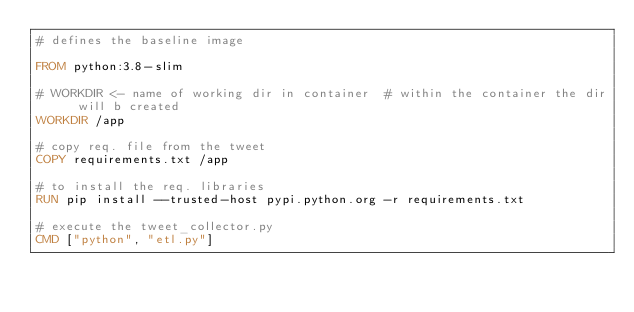<code> <loc_0><loc_0><loc_500><loc_500><_Dockerfile_># defines the baseline image

FROM python:3.8-slim

# WORKDIR <- name of working dir in container  # within the container the dir will b created
WORKDIR /app

# copy req. file from the tweet
COPY requirements.txt /app

# to install the req. libraries
RUN pip install --trusted-host pypi.python.org -r requirements.txt

# execute the tweet_collector.py
CMD ["python", "etl.py"]</code> 